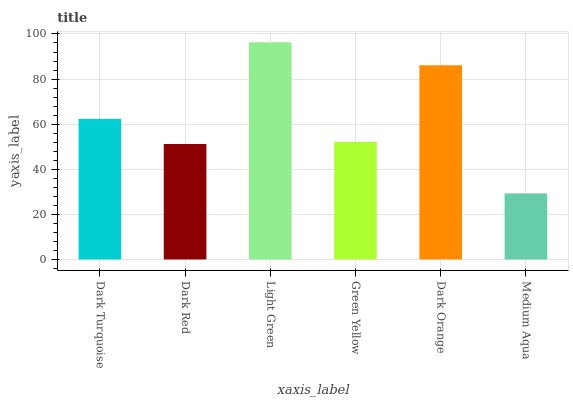Is Medium Aqua the minimum?
Answer yes or no. Yes. Is Light Green the maximum?
Answer yes or no. Yes. Is Dark Red the minimum?
Answer yes or no. No. Is Dark Red the maximum?
Answer yes or no. No. Is Dark Turquoise greater than Dark Red?
Answer yes or no. Yes. Is Dark Red less than Dark Turquoise?
Answer yes or no. Yes. Is Dark Red greater than Dark Turquoise?
Answer yes or no. No. Is Dark Turquoise less than Dark Red?
Answer yes or no. No. Is Dark Turquoise the high median?
Answer yes or no. Yes. Is Green Yellow the low median?
Answer yes or no. Yes. Is Dark Red the high median?
Answer yes or no. No. Is Dark Orange the low median?
Answer yes or no. No. 